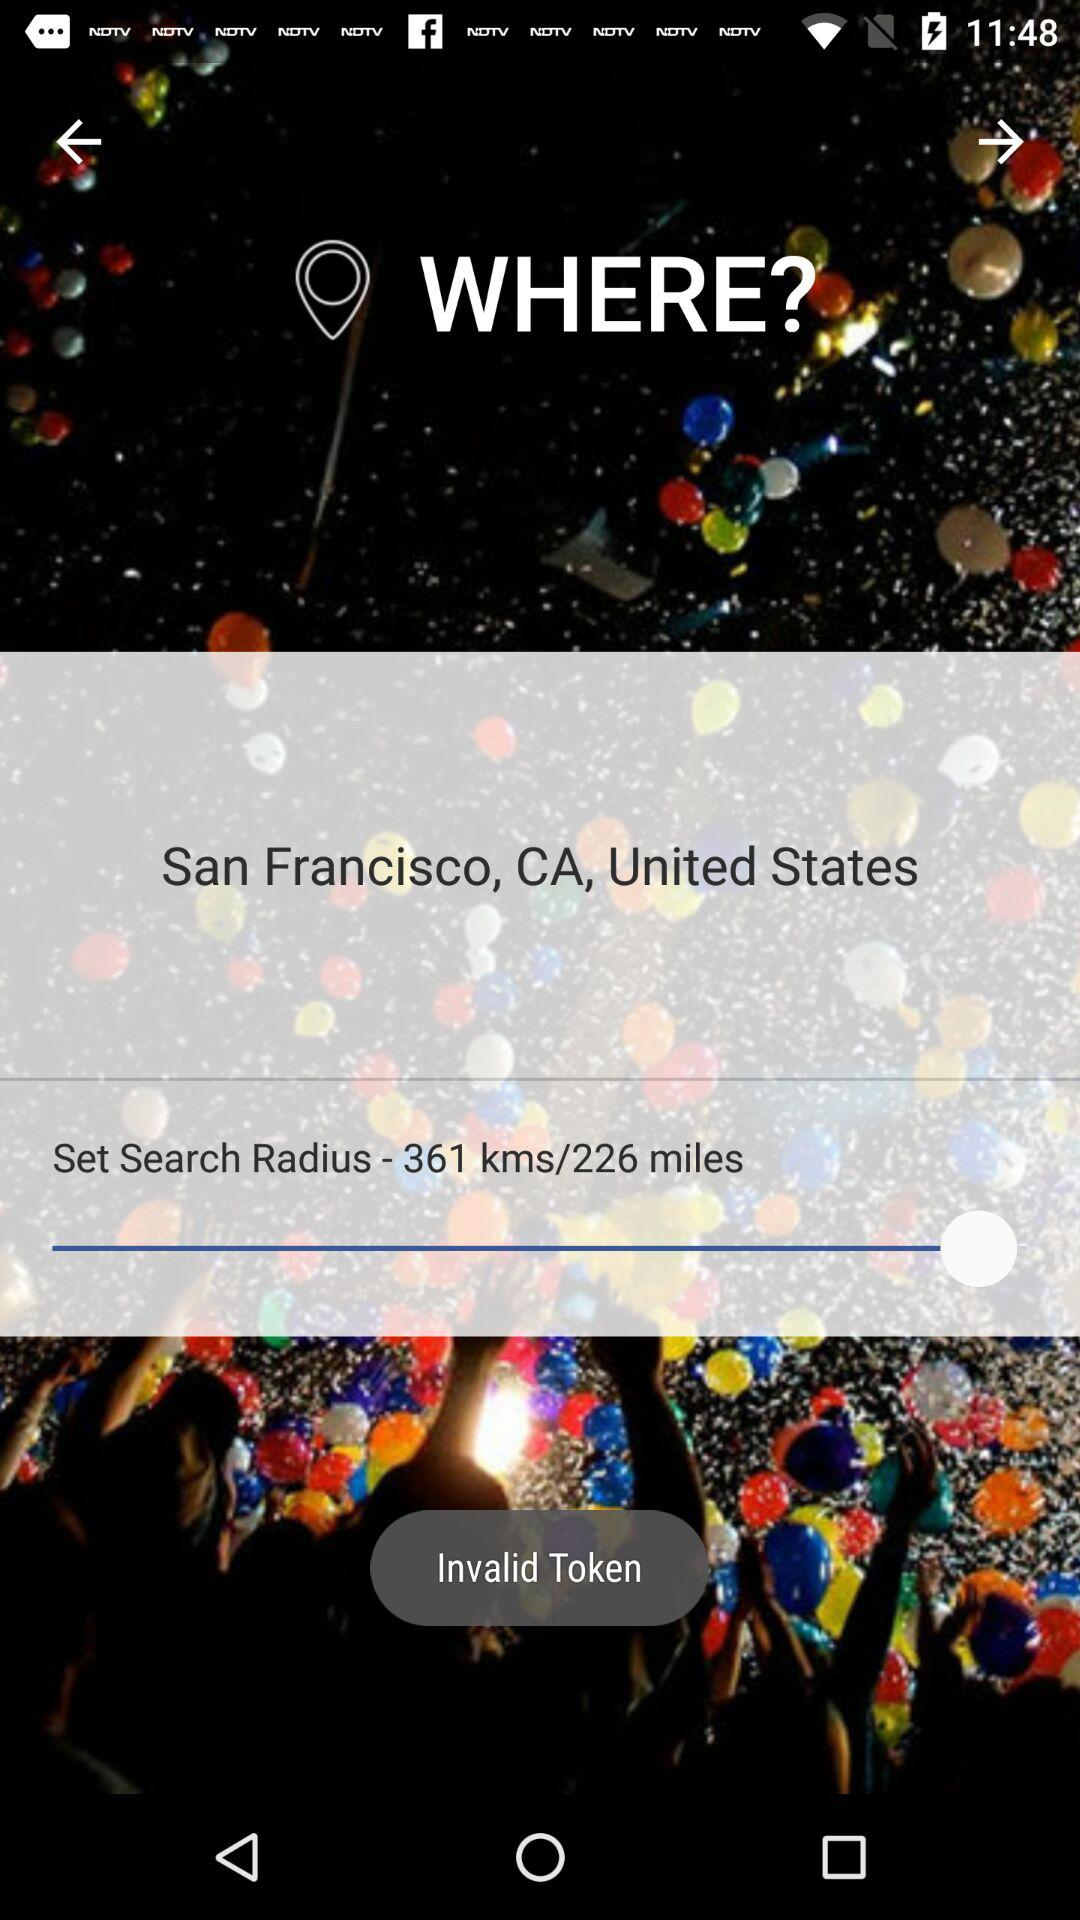What is the set search radius? The set search radius is 361 kilometers or 226 miles. 